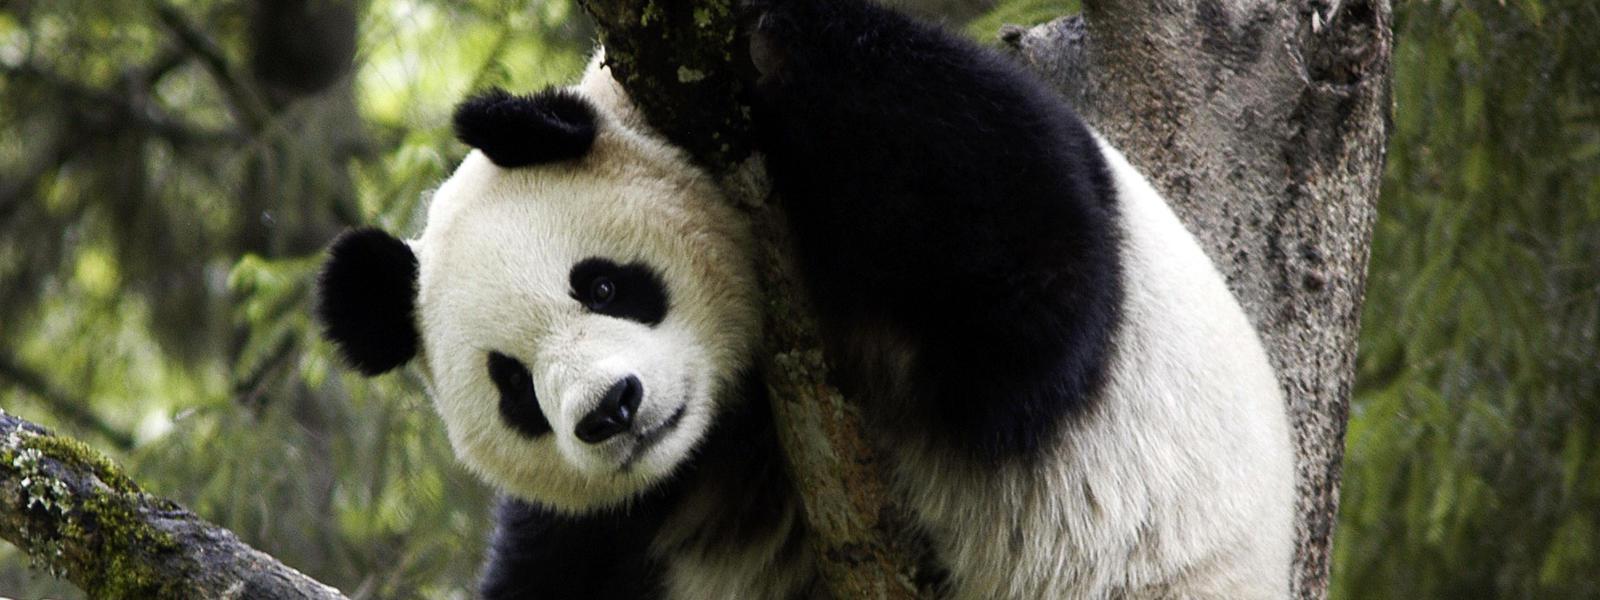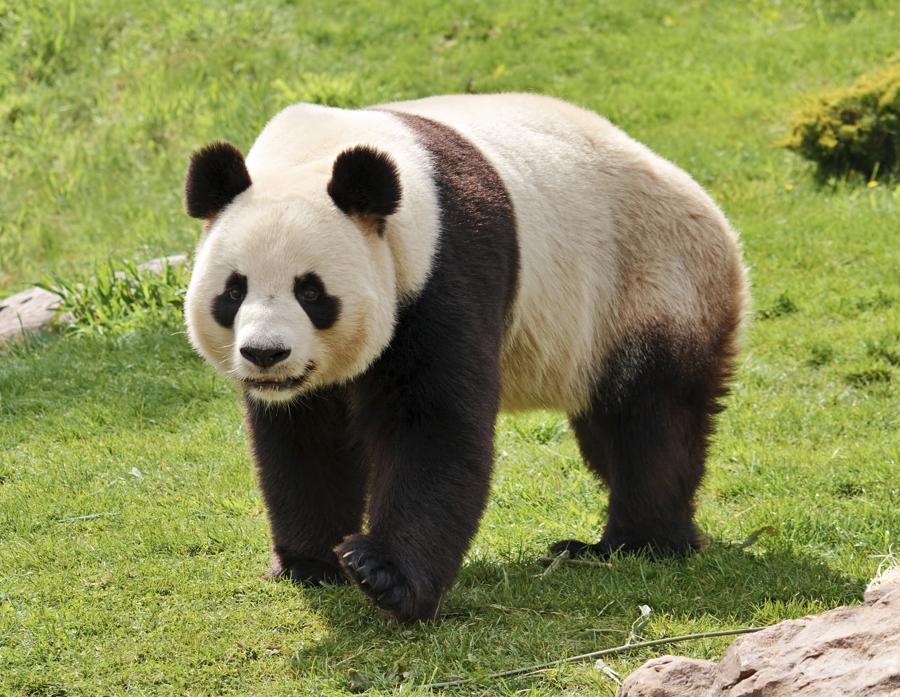The first image is the image on the left, the second image is the image on the right. Analyze the images presented: Is the assertion "The panda in the left photo is holding a piece of wood in its paw." valid? Answer yes or no. No. The first image is the image on the left, the second image is the image on the right. For the images displayed, is the sentence "The panda in one of the images is standing on all fours in the grass." factually correct? Answer yes or no. Yes. 